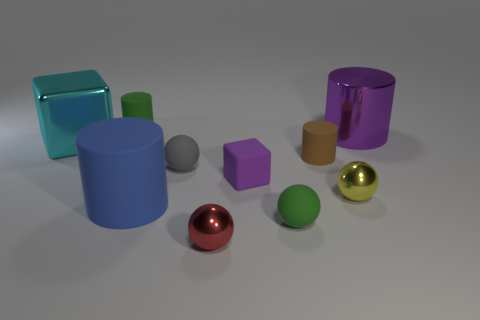What number of matte things are either large cyan blocks or green cylinders?
Offer a very short reply. 1. Do the big cylinder that is in front of the tiny brown matte cylinder and the thing behind the purple cylinder have the same material?
Ensure brevity in your answer.  Yes. What is the color of the big thing that is made of the same material as the gray ball?
Your answer should be very brief. Blue. Are there more big blue cylinders to the left of the small cube than large metal things in front of the large blue rubber cylinder?
Offer a terse response. Yes. Are there any metallic objects?
Your response must be concise. Yes. There is a large cylinder that is the same color as the matte block; what is its material?
Offer a very short reply. Metal. What number of objects are big purple shiny balls or cyan shiny cubes?
Ensure brevity in your answer.  1. Are there any large balls of the same color as the metal block?
Your answer should be compact. No. There is a large metallic thing to the left of the small yellow metal thing; how many yellow shiny spheres are left of it?
Your response must be concise. 0. Are there more yellow metal objects than large yellow blocks?
Ensure brevity in your answer.  Yes. 